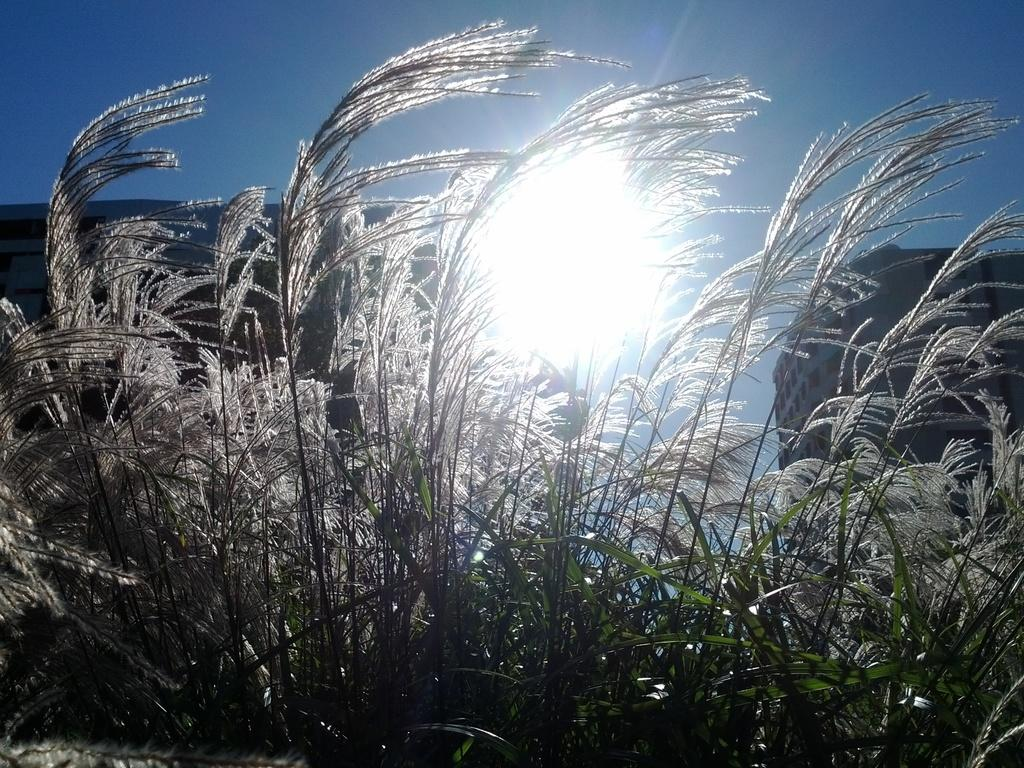What type of vegetation is present in the front of the image? There are bushes in the front of the image. What structures can be seen in the background of the image? There are two buildings in the background of the image. What celestial body is visible in the image? The sun is visible in the image. What else can be seen in the sky in the image? The sky is visible in the image. How many toes can be seen on the rat in the image? There is no rat present in the image, so it is not possible to determine the number of toes on a rat. 